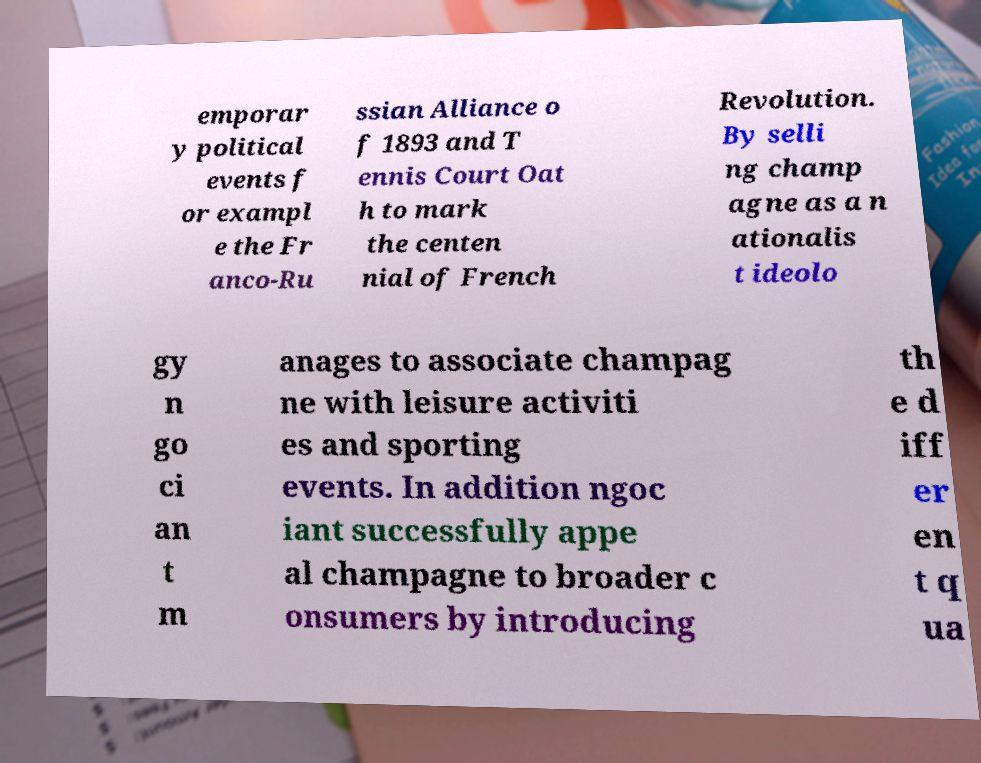Can you read and provide the text displayed in the image?This photo seems to have some interesting text. Can you extract and type it out for me? emporar y political events f or exampl e the Fr anco-Ru ssian Alliance o f 1893 and T ennis Court Oat h to mark the centen nial of French Revolution. By selli ng champ agne as a n ationalis t ideolo gy n go ci an t m anages to associate champag ne with leisure activiti es and sporting events. In addition ngoc iant successfully appe al champagne to broader c onsumers by introducing th e d iff er en t q ua 